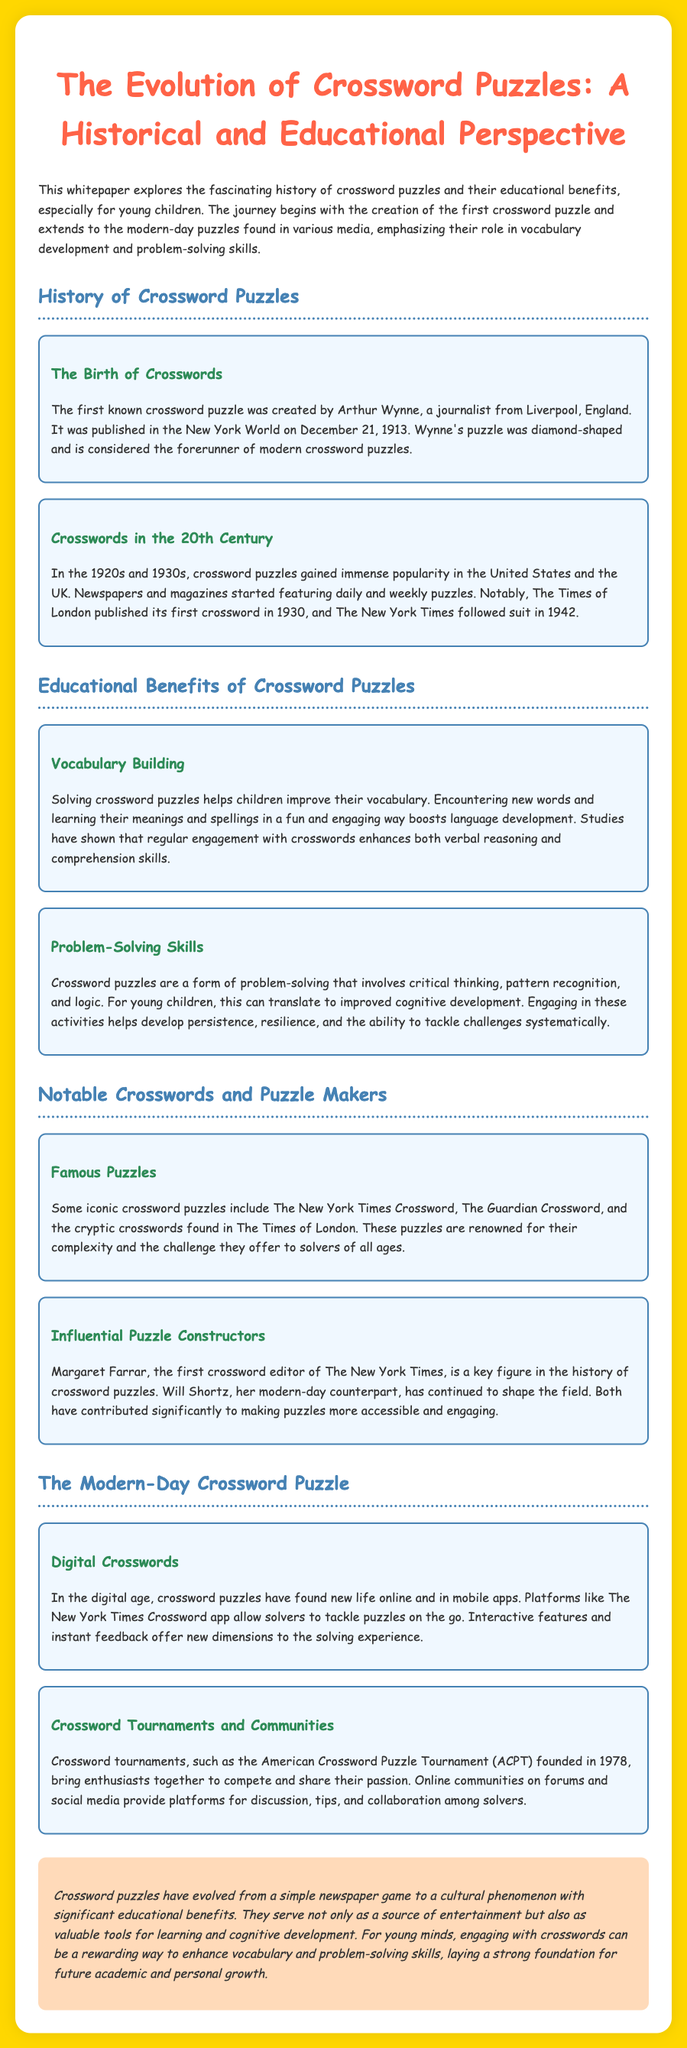what date was the first crossword puzzle published? The first crossword puzzle was published on December 21, 1913.
Answer: December 21, 1913 who created the first known crossword puzzle? The first known crossword puzzle was created by Arthur Wynne.
Answer: Arthur Wynne which newspaper published its first crossword in 1930? The Times of London published its first crossword in 1930.
Answer: The Times of London what educational benefit do crossword puzzles provide for children? Crossword puzzles help children improve their vocabulary.
Answer: vocabulary who was the first crossword editor of The New York Times? Margaret Farrar was the first crossword editor of The New York Times.
Answer: Margaret Farrar what is the name of the tournament founded in 1978? The American Crossword Puzzle Tournament (ACPT) was founded in 1978.
Answer: ACPT how do modern crossword puzzles differ from the original ones? Modern crossword puzzles are available online and in mobile apps.
Answer: online and mobile apps what role do crossword puzzles play in cognitive development? Crossword puzzles help develop persistence, resilience, and the ability to tackle challenges systematically.
Answer: cognitive development what color is the background of the document? The background color of the document is golden.
Answer: golden 